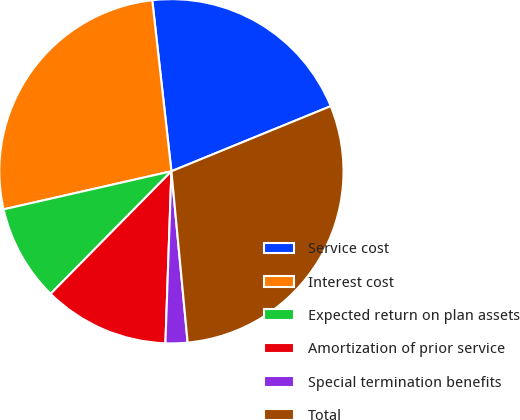Convert chart. <chart><loc_0><loc_0><loc_500><loc_500><pie_chart><fcel>Service cost<fcel>Interest cost<fcel>Expected return on plan assets<fcel>Amortization of prior service<fcel>Special termination benefits<fcel>Total<nl><fcel>20.6%<fcel>26.78%<fcel>9.06%<fcel>11.83%<fcel>2.06%<fcel>29.67%<nl></chart> 